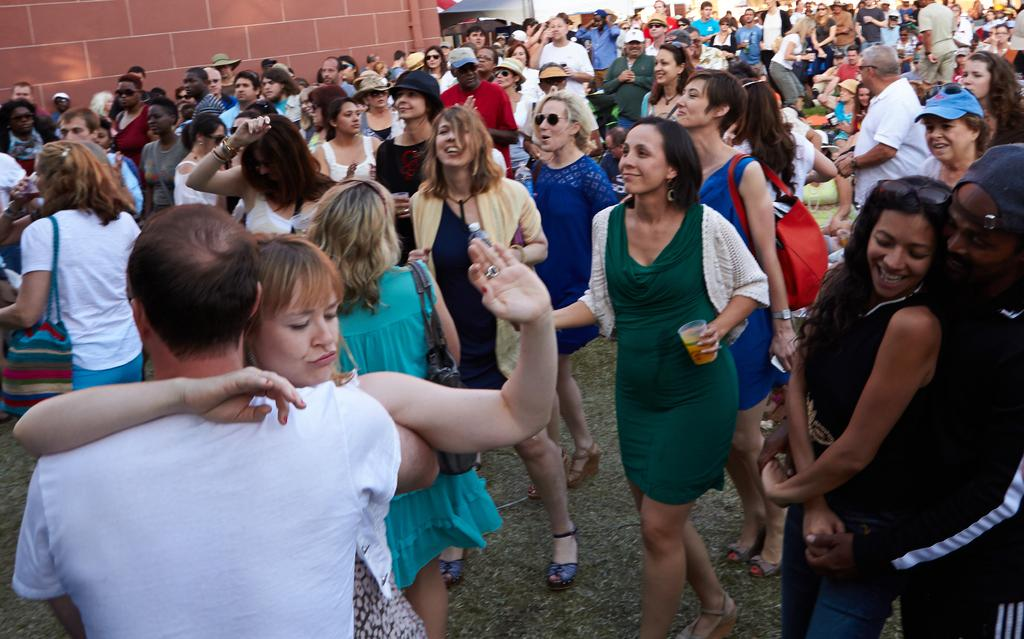How many people are in the image? There are people in the image, but the exact number is not specified. What are the people doing in the image? The people are doing different activities in the image. What can be seen in the background of the image? There is a wall in the background of the image. What type of sweater is the person wearing while ploughing the field in the image? There is no person ploughing a field or wearing a sweater in the image. 